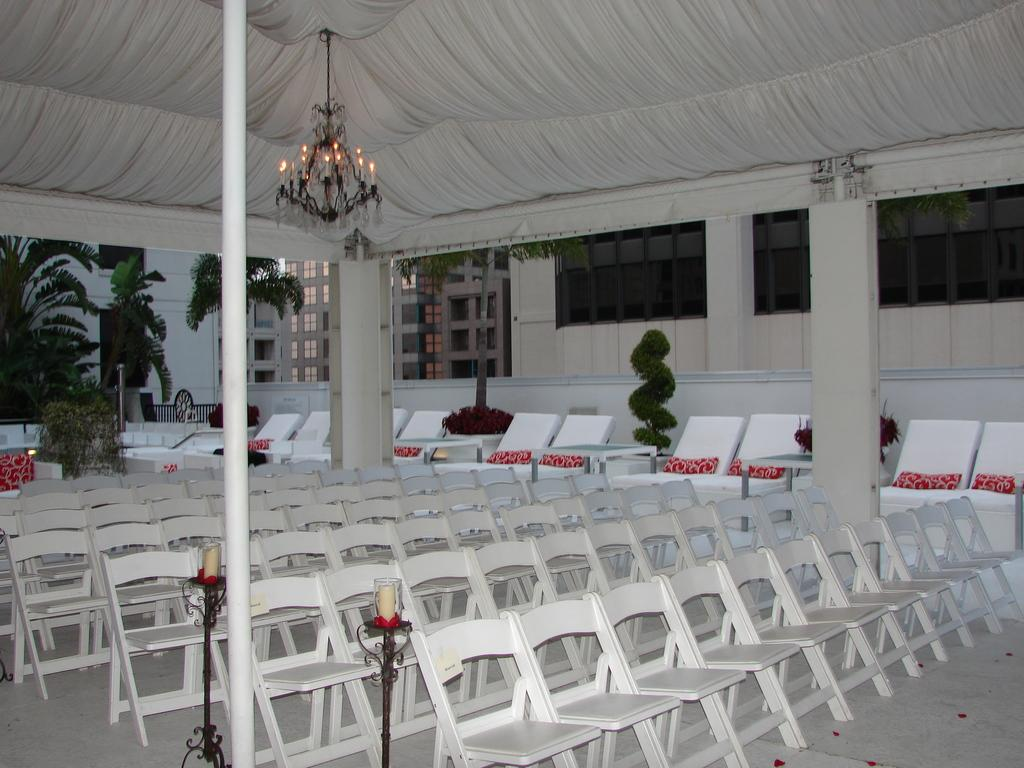What type of furniture can be seen in the image? There are chairs in the image. What can be seen in the distance in the image? There are buildings and plants in the background of the image. What type of lighting fixture is present in the image? There is a chandelier in the image. On what is the chandelier placed? The chandelier is on a white object. Can you see a tray being used to serve food in the image? There is no tray visible in the image. Is there a horse present in the image? There is no horse present in the image. 